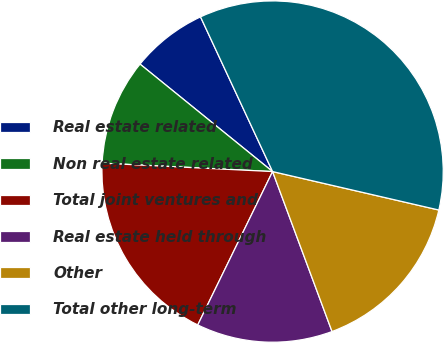Convert chart. <chart><loc_0><loc_0><loc_500><loc_500><pie_chart><fcel>Real estate related<fcel>Non real estate related<fcel>Total joint ventures and<fcel>Real estate held through<fcel>Other<fcel>Total other long-term<nl><fcel>7.22%<fcel>10.06%<fcel>18.56%<fcel>12.89%<fcel>15.72%<fcel>35.56%<nl></chart> 